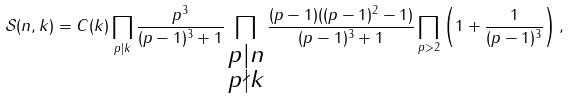Convert formula to latex. <formula><loc_0><loc_0><loc_500><loc_500>\mathcal { S } ( n , k ) = C ( k ) \prod _ { p | k } \frac { p ^ { 3 } } { ( p - 1 ) ^ { 3 } + 1 } \prod _ { \substack { p | n \\ p \nmid k } } \frac { ( p - 1 ) ( ( p - 1 ) ^ { 2 } - 1 ) } { ( p - 1 ) ^ { 3 } + 1 } \prod _ { p > 2 } \left ( 1 + \frac { 1 } { ( p - 1 ) ^ { 3 } } \right ) ,</formula> 